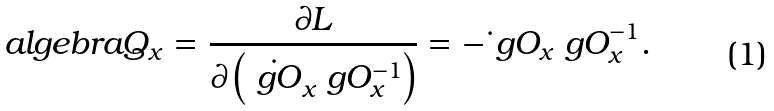<formula> <loc_0><loc_0><loc_500><loc_500>\ a l g e b r a { Q } _ { x } = \frac { \partial L } { \partial \left ( \dot { \ g O } _ { x } \ g O _ { x } ^ { - 1 } \right ) } = - \dot { \ } g O _ { x } \ g O _ { x } ^ { - 1 } .</formula> 